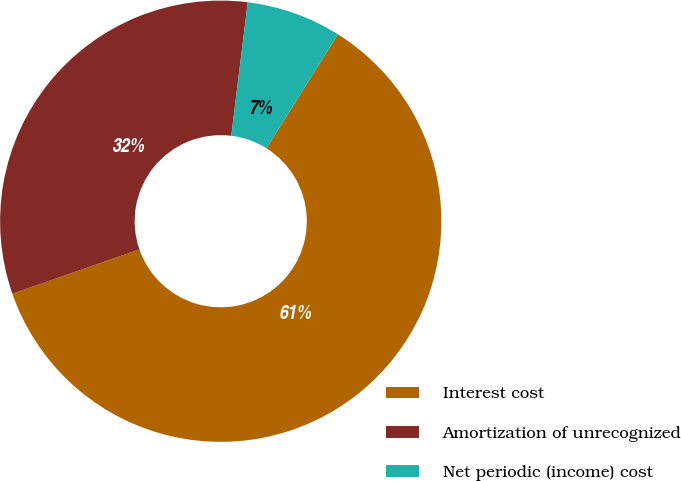Convert chart to OTSL. <chart><loc_0><loc_0><loc_500><loc_500><pie_chart><fcel>Interest cost<fcel>Amortization of unrecognized<fcel>Net periodic (income) cost<nl><fcel>60.76%<fcel>32.28%<fcel>6.96%<nl></chart> 